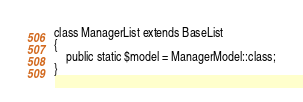<code> <loc_0><loc_0><loc_500><loc_500><_PHP_>
class ManagerList extends BaseList
{
    public static $model = ManagerModel::class;
}
</code> 